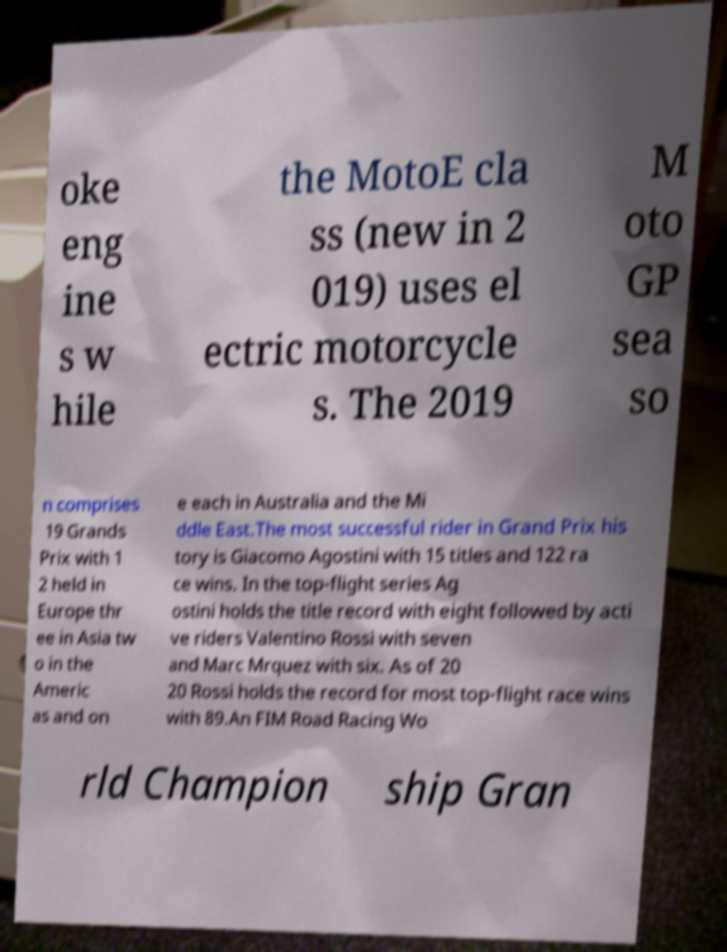Can you accurately transcribe the text from the provided image for me? oke eng ine s w hile the MotoE cla ss (new in 2 019) uses el ectric motorcycle s. The 2019 M oto GP sea so n comprises 19 Grands Prix with 1 2 held in Europe thr ee in Asia tw o in the Americ as and on e each in Australia and the Mi ddle East.The most successful rider in Grand Prix his tory is Giacomo Agostini with 15 titles and 122 ra ce wins. In the top-flight series Ag ostini holds the title record with eight followed by acti ve riders Valentino Rossi with seven and Marc Mrquez with six. As of 20 20 Rossi holds the record for most top-flight race wins with 89.An FIM Road Racing Wo rld Champion ship Gran 